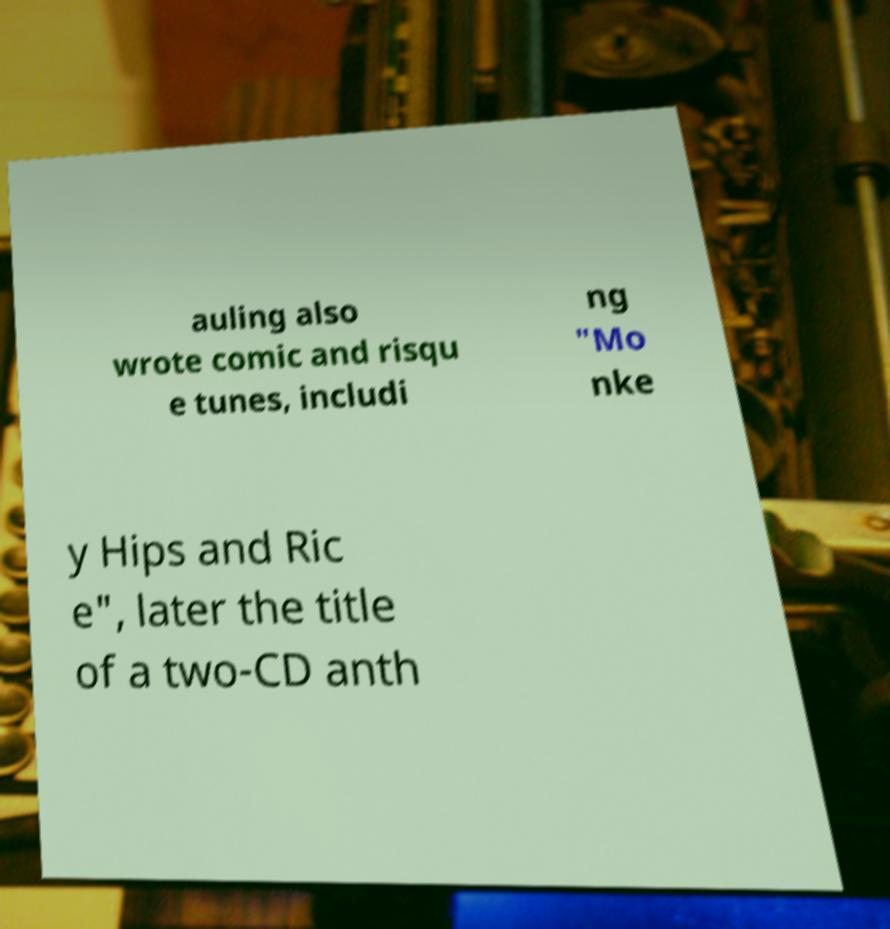There's text embedded in this image that I need extracted. Can you transcribe it verbatim? auling also wrote comic and risqu e tunes, includi ng "Mo nke y Hips and Ric e", later the title of a two-CD anth 